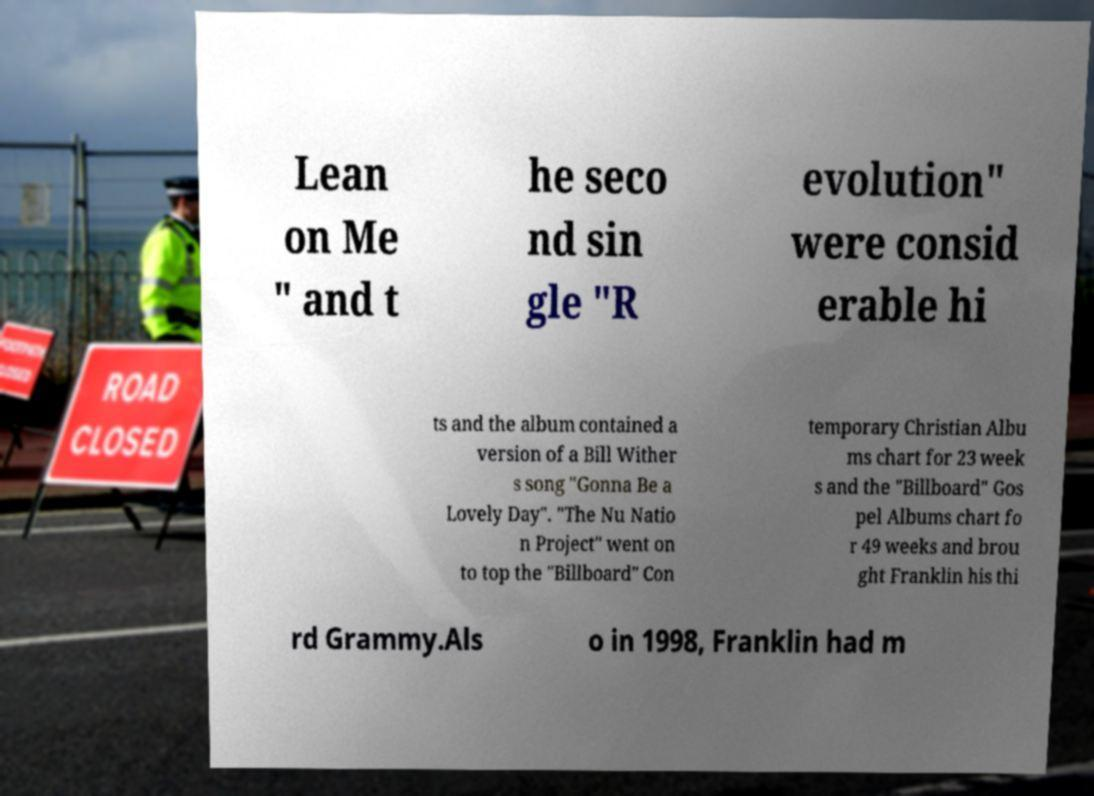Please read and relay the text visible in this image. What does it say? Lean on Me " and t he seco nd sin gle "R evolution" were consid erable hi ts and the album contained a version of a Bill Wither s song "Gonna Be a Lovely Day". "The Nu Natio n Project" went on to top the "Billboard" Con temporary Christian Albu ms chart for 23 week s and the "Billboard" Gos pel Albums chart fo r 49 weeks and brou ght Franklin his thi rd Grammy.Als o in 1998, Franklin had m 